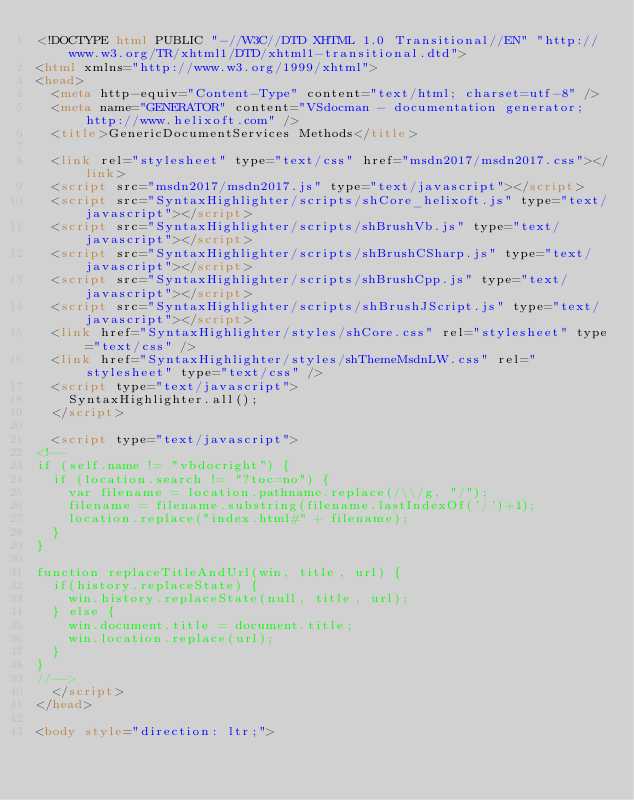<code> <loc_0><loc_0><loc_500><loc_500><_HTML_><!DOCTYPE html PUBLIC "-//W3C//DTD XHTML 1.0 Transitional//EN" "http://www.w3.org/TR/xhtml1/DTD/xhtml1-transitional.dtd">
<html xmlns="http://www.w3.org/1999/xhtml">
<head>
	<meta http-equiv="Content-Type" content="text/html; charset=utf-8" />
	<meta name="GENERATOR" content="VSdocman - documentation generator; http://www.helixoft.com" />
	<title>GenericDocumentServices Methods</title>

	<link rel="stylesheet" type="text/css" href="msdn2017/msdn2017.css"></link>
	<script src="msdn2017/msdn2017.js" type="text/javascript"></script>
	<script src="SyntaxHighlighter/scripts/shCore_helixoft.js" type="text/javascript"></script>
	<script src="SyntaxHighlighter/scripts/shBrushVb.js" type="text/javascript"></script>
	<script src="SyntaxHighlighter/scripts/shBrushCSharp.js" type="text/javascript"></script>
	<script src="SyntaxHighlighter/scripts/shBrushCpp.js" type="text/javascript"></script>
	<script src="SyntaxHighlighter/scripts/shBrushJScript.js" type="text/javascript"></script>
	<link href="SyntaxHighlighter/styles/shCore.css" rel="stylesheet" type="text/css" />
	<link href="SyntaxHighlighter/styles/shThemeMsdnLW.css" rel="stylesheet" type="text/css" />
	<script type="text/javascript">
		SyntaxHighlighter.all();
	</script>				

	<script type="text/javascript">
<!--
if (self.name != "vbdocright") {
	if (location.search != "?toc=no") {
		var filename = location.pathname.replace(/\\/g, "/");
		filename = filename.substring(filename.lastIndexOf('/')+1);
		location.replace("index.html#" + filename);
	} 
}

function replaceTitleAndUrl(win, title, url) {
	if(history.replaceState) {
		win.history.replaceState(null, title, url);
	} else {
		win.document.title = document.title;
		win.location.replace(url);
	}
}
//-->
	</script>	
</head>

<body style="direction: ltr;"></code> 